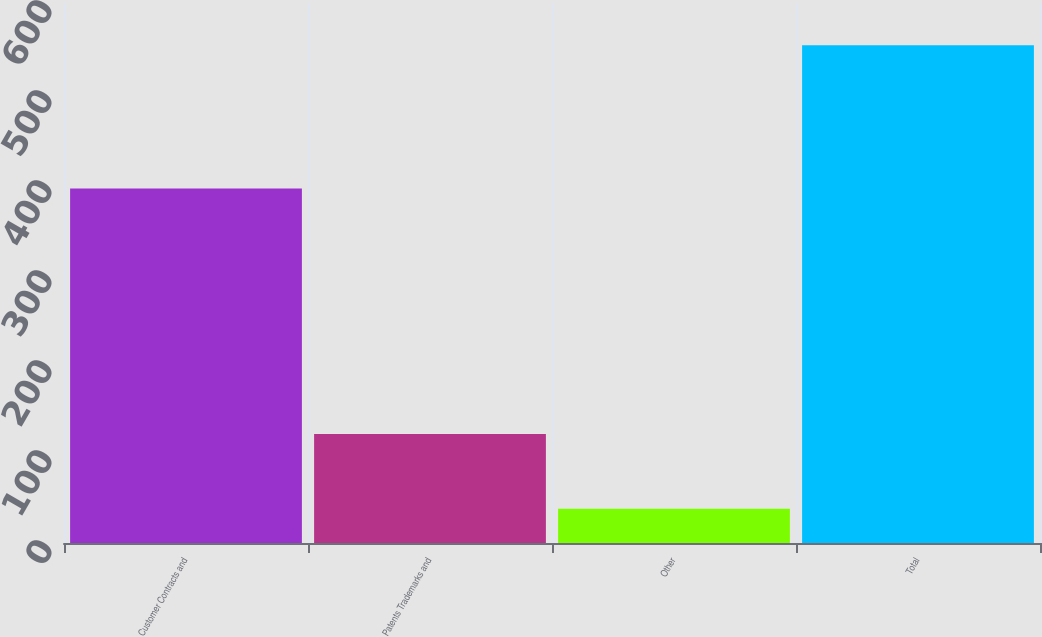Convert chart. <chart><loc_0><loc_0><loc_500><loc_500><bar_chart><fcel>Customer Contracts and<fcel>Patents Trademarks and<fcel>Other<fcel>Total<nl><fcel>394<fcel>121<fcel>38<fcel>553<nl></chart> 